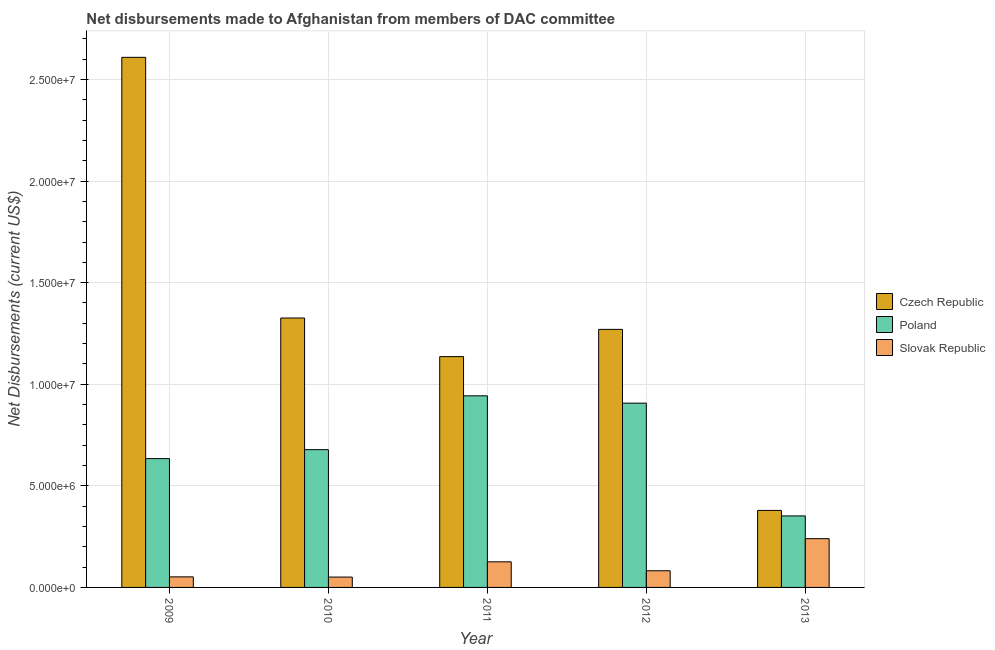How many different coloured bars are there?
Provide a succinct answer. 3. How many groups of bars are there?
Provide a succinct answer. 5. Are the number of bars per tick equal to the number of legend labels?
Keep it short and to the point. Yes. Are the number of bars on each tick of the X-axis equal?
Provide a succinct answer. Yes. How many bars are there on the 2nd tick from the right?
Make the answer very short. 3. What is the label of the 2nd group of bars from the left?
Give a very brief answer. 2010. What is the net disbursements made by czech republic in 2011?
Provide a short and direct response. 1.14e+07. Across all years, what is the maximum net disbursements made by czech republic?
Offer a terse response. 2.61e+07. Across all years, what is the minimum net disbursements made by poland?
Your answer should be compact. 3.52e+06. In which year was the net disbursements made by poland minimum?
Offer a very short reply. 2013. What is the total net disbursements made by poland in the graph?
Keep it short and to the point. 3.51e+07. What is the difference between the net disbursements made by czech republic in 2010 and that in 2011?
Your response must be concise. 1.90e+06. What is the difference between the net disbursements made by poland in 2010 and the net disbursements made by czech republic in 2012?
Offer a terse response. -2.29e+06. What is the average net disbursements made by czech republic per year?
Give a very brief answer. 1.34e+07. In the year 2013, what is the difference between the net disbursements made by czech republic and net disbursements made by poland?
Offer a terse response. 0. What is the ratio of the net disbursements made by poland in 2011 to that in 2012?
Offer a terse response. 1.04. Is the net disbursements made by czech republic in 2009 less than that in 2013?
Your answer should be compact. No. Is the difference between the net disbursements made by slovak republic in 2009 and 2010 greater than the difference between the net disbursements made by czech republic in 2009 and 2010?
Make the answer very short. No. What is the difference between the highest and the second highest net disbursements made by czech republic?
Your answer should be very brief. 1.28e+07. What is the difference between the highest and the lowest net disbursements made by poland?
Offer a very short reply. 5.91e+06. What does the 2nd bar from the left in 2013 represents?
Your answer should be very brief. Poland. What does the 1st bar from the right in 2011 represents?
Provide a succinct answer. Slovak Republic. How many bars are there?
Your response must be concise. 15. Are all the bars in the graph horizontal?
Ensure brevity in your answer.  No. How many years are there in the graph?
Your answer should be compact. 5. How many legend labels are there?
Your response must be concise. 3. How are the legend labels stacked?
Make the answer very short. Vertical. What is the title of the graph?
Keep it short and to the point. Net disbursements made to Afghanistan from members of DAC committee. What is the label or title of the X-axis?
Give a very brief answer. Year. What is the label or title of the Y-axis?
Offer a very short reply. Net Disbursements (current US$). What is the Net Disbursements (current US$) in Czech Republic in 2009?
Keep it short and to the point. 2.61e+07. What is the Net Disbursements (current US$) in Poland in 2009?
Your answer should be very brief. 6.34e+06. What is the Net Disbursements (current US$) in Slovak Republic in 2009?
Offer a terse response. 5.20e+05. What is the Net Disbursements (current US$) of Czech Republic in 2010?
Offer a very short reply. 1.33e+07. What is the Net Disbursements (current US$) in Poland in 2010?
Give a very brief answer. 6.78e+06. What is the Net Disbursements (current US$) in Slovak Republic in 2010?
Ensure brevity in your answer.  5.10e+05. What is the Net Disbursements (current US$) in Czech Republic in 2011?
Ensure brevity in your answer.  1.14e+07. What is the Net Disbursements (current US$) of Poland in 2011?
Keep it short and to the point. 9.43e+06. What is the Net Disbursements (current US$) in Slovak Republic in 2011?
Provide a short and direct response. 1.26e+06. What is the Net Disbursements (current US$) of Czech Republic in 2012?
Ensure brevity in your answer.  1.27e+07. What is the Net Disbursements (current US$) of Poland in 2012?
Offer a terse response. 9.07e+06. What is the Net Disbursements (current US$) of Slovak Republic in 2012?
Offer a terse response. 8.20e+05. What is the Net Disbursements (current US$) in Czech Republic in 2013?
Your response must be concise. 3.79e+06. What is the Net Disbursements (current US$) of Poland in 2013?
Keep it short and to the point. 3.52e+06. What is the Net Disbursements (current US$) of Slovak Republic in 2013?
Offer a very short reply. 2.40e+06. Across all years, what is the maximum Net Disbursements (current US$) of Czech Republic?
Ensure brevity in your answer.  2.61e+07. Across all years, what is the maximum Net Disbursements (current US$) in Poland?
Your answer should be very brief. 9.43e+06. Across all years, what is the maximum Net Disbursements (current US$) of Slovak Republic?
Your response must be concise. 2.40e+06. Across all years, what is the minimum Net Disbursements (current US$) in Czech Republic?
Your response must be concise. 3.79e+06. Across all years, what is the minimum Net Disbursements (current US$) in Poland?
Give a very brief answer. 3.52e+06. Across all years, what is the minimum Net Disbursements (current US$) in Slovak Republic?
Provide a succinct answer. 5.10e+05. What is the total Net Disbursements (current US$) in Czech Republic in the graph?
Provide a short and direct response. 6.72e+07. What is the total Net Disbursements (current US$) in Poland in the graph?
Your response must be concise. 3.51e+07. What is the total Net Disbursements (current US$) in Slovak Republic in the graph?
Offer a terse response. 5.51e+06. What is the difference between the Net Disbursements (current US$) of Czech Republic in 2009 and that in 2010?
Ensure brevity in your answer.  1.28e+07. What is the difference between the Net Disbursements (current US$) of Poland in 2009 and that in 2010?
Make the answer very short. -4.40e+05. What is the difference between the Net Disbursements (current US$) in Slovak Republic in 2009 and that in 2010?
Give a very brief answer. 10000. What is the difference between the Net Disbursements (current US$) in Czech Republic in 2009 and that in 2011?
Give a very brief answer. 1.47e+07. What is the difference between the Net Disbursements (current US$) of Poland in 2009 and that in 2011?
Offer a terse response. -3.09e+06. What is the difference between the Net Disbursements (current US$) in Slovak Republic in 2009 and that in 2011?
Provide a short and direct response. -7.40e+05. What is the difference between the Net Disbursements (current US$) of Czech Republic in 2009 and that in 2012?
Your answer should be compact. 1.34e+07. What is the difference between the Net Disbursements (current US$) of Poland in 2009 and that in 2012?
Your answer should be very brief. -2.73e+06. What is the difference between the Net Disbursements (current US$) in Slovak Republic in 2009 and that in 2012?
Keep it short and to the point. -3.00e+05. What is the difference between the Net Disbursements (current US$) in Czech Republic in 2009 and that in 2013?
Keep it short and to the point. 2.23e+07. What is the difference between the Net Disbursements (current US$) in Poland in 2009 and that in 2013?
Provide a short and direct response. 2.82e+06. What is the difference between the Net Disbursements (current US$) of Slovak Republic in 2009 and that in 2013?
Provide a short and direct response. -1.88e+06. What is the difference between the Net Disbursements (current US$) of Czech Republic in 2010 and that in 2011?
Your answer should be very brief. 1.90e+06. What is the difference between the Net Disbursements (current US$) in Poland in 2010 and that in 2011?
Offer a terse response. -2.65e+06. What is the difference between the Net Disbursements (current US$) in Slovak Republic in 2010 and that in 2011?
Your answer should be compact. -7.50e+05. What is the difference between the Net Disbursements (current US$) in Czech Republic in 2010 and that in 2012?
Offer a terse response. 5.60e+05. What is the difference between the Net Disbursements (current US$) in Poland in 2010 and that in 2012?
Make the answer very short. -2.29e+06. What is the difference between the Net Disbursements (current US$) of Slovak Republic in 2010 and that in 2012?
Provide a short and direct response. -3.10e+05. What is the difference between the Net Disbursements (current US$) in Czech Republic in 2010 and that in 2013?
Your answer should be very brief. 9.47e+06. What is the difference between the Net Disbursements (current US$) of Poland in 2010 and that in 2013?
Offer a very short reply. 3.26e+06. What is the difference between the Net Disbursements (current US$) of Slovak Republic in 2010 and that in 2013?
Make the answer very short. -1.89e+06. What is the difference between the Net Disbursements (current US$) in Czech Republic in 2011 and that in 2012?
Offer a very short reply. -1.34e+06. What is the difference between the Net Disbursements (current US$) of Poland in 2011 and that in 2012?
Keep it short and to the point. 3.60e+05. What is the difference between the Net Disbursements (current US$) in Slovak Republic in 2011 and that in 2012?
Your answer should be very brief. 4.40e+05. What is the difference between the Net Disbursements (current US$) of Czech Republic in 2011 and that in 2013?
Your response must be concise. 7.57e+06. What is the difference between the Net Disbursements (current US$) in Poland in 2011 and that in 2013?
Keep it short and to the point. 5.91e+06. What is the difference between the Net Disbursements (current US$) of Slovak Republic in 2011 and that in 2013?
Your answer should be compact. -1.14e+06. What is the difference between the Net Disbursements (current US$) in Czech Republic in 2012 and that in 2013?
Offer a terse response. 8.91e+06. What is the difference between the Net Disbursements (current US$) in Poland in 2012 and that in 2013?
Offer a terse response. 5.55e+06. What is the difference between the Net Disbursements (current US$) in Slovak Republic in 2012 and that in 2013?
Make the answer very short. -1.58e+06. What is the difference between the Net Disbursements (current US$) of Czech Republic in 2009 and the Net Disbursements (current US$) of Poland in 2010?
Provide a succinct answer. 1.93e+07. What is the difference between the Net Disbursements (current US$) of Czech Republic in 2009 and the Net Disbursements (current US$) of Slovak Republic in 2010?
Ensure brevity in your answer.  2.56e+07. What is the difference between the Net Disbursements (current US$) in Poland in 2009 and the Net Disbursements (current US$) in Slovak Republic in 2010?
Your answer should be compact. 5.83e+06. What is the difference between the Net Disbursements (current US$) in Czech Republic in 2009 and the Net Disbursements (current US$) in Poland in 2011?
Provide a succinct answer. 1.67e+07. What is the difference between the Net Disbursements (current US$) of Czech Republic in 2009 and the Net Disbursements (current US$) of Slovak Republic in 2011?
Keep it short and to the point. 2.48e+07. What is the difference between the Net Disbursements (current US$) of Poland in 2009 and the Net Disbursements (current US$) of Slovak Republic in 2011?
Provide a succinct answer. 5.08e+06. What is the difference between the Net Disbursements (current US$) in Czech Republic in 2009 and the Net Disbursements (current US$) in Poland in 2012?
Offer a very short reply. 1.70e+07. What is the difference between the Net Disbursements (current US$) in Czech Republic in 2009 and the Net Disbursements (current US$) in Slovak Republic in 2012?
Your answer should be very brief. 2.53e+07. What is the difference between the Net Disbursements (current US$) of Poland in 2009 and the Net Disbursements (current US$) of Slovak Republic in 2012?
Offer a very short reply. 5.52e+06. What is the difference between the Net Disbursements (current US$) of Czech Republic in 2009 and the Net Disbursements (current US$) of Poland in 2013?
Your answer should be very brief. 2.26e+07. What is the difference between the Net Disbursements (current US$) of Czech Republic in 2009 and the Net Disbursements (current US$) of Slovak Republic in 2013?
Your response must be concise. 2.37e+07. What is the difference between the Net Disbursements (current US$) in Poland in 2009 and the Net Disbursements (current US$) in Slovak Republic in 2013?
Provide a succinct answer. 3.94e+06. What is the difference between the Net Disbursements (current US$) of Czech Republic in 2010 and the Net Disbursements (current US$) of Poland in 2011?
Give a very brief answer. 3.83e+06. What is the difference between the Net Disbursements (current US$) in Poland in 2010 and the Net Disbursements (current US$) in Slovak Republic in 2011?
Provide a short and direct response. 5.52e+06. What is the difference between the Net Disbursements (current US$) in Czech Republic in 2010 and the Net Disbursements (current US$) in Poland in 2012?
Provide a succinct answer. 4.19e+06. What is the difference between the Net Disbursements (current US$) in Czech Republic in 2010 and the Net Disbursements (current US$) in Slovak Republic in 2012?
Give a very brief answer. 1.24e+07. What is the difference between the Net Disbursements (current US$) of Poland in 2010 and the Net Disbursements (current US$) of Slovak Republic in 2012?
Ensure brevity in your answer.  5.96e+06. What is the difference between the Net Disbursements (current US$) of Czech Republic in 2010 and the Net Disbursements (current US$) of Poland in 2013?
Provide a short and direct response. 9.74e+06. What is the difference between the Net Disbursements (current US$) of Czech Republic in 2010 and the Net Disbursements (current US$) of Slovak Republic in 2013?
Keep it short and to the point. 1.09e+07. What is the difference between the Net Disbursements (current US$) of Poland in 2010 and the Net Disbursements (current US$) of Slovak Republic in 2013?
Ensure brevity in your answer.  4.38e+06. What is the difference between the Net Disbursements (current US$) in Czech Republic in 2011 and the Net Disbursements (current US$) in Poland in 2012?
Your response must be concise. 2.29e+06. What is the difference between the Net Disbursements (current US$) of Czech Republic in 2011 and the Net Disbursements (current US$) of Slovak Republic in 2012?
Make the answer very short. 1.05e+07. What is the difference between the Net Disbursements (current US$) of Poland in 2011 and the Net Disbursements (current US$) of Slovak Republic in 2012?
Ensure brevity in your answer.  8.61e+06. What is the difference between the Net Disbursements (current US$) of Czech Republic in 2011 and the Net Disbursements (current US$) of Poland in 2013?
Make the answer very short. 7.84e+06. What is the difference between the Net Disbursements (current US$) of Czech Republic in 2011 and the Net Disbursements (current US$) of Slovak Republic in 2013?
Provide a short and direct response. 8.96e+06. What is the difference between the Net Disbursements (current US$) of Poland in 2011 and the Net Disbursements (current US$) of Slovak Republic in 2013?
Give a very brief answer. 7.03e+06. What is the difference between the Net Disbursements (current US$) in Czech Republic in 2012 and the Net Disbursements (current US$) in Poland in 2013?
Provide a succinct answer. 9.18e+06. What is the difference between the Net Disbursements (current US$) in Czech Republic in 2012 and the Net Disbursements (current US$) in Slovak Republic in 2013?
Your response must be concise. 1.03e+07. What is the difference between the Net Disbursements (current US$) of Poland in 2012 and the Net Disbursements (current US$) of Slovak Republic in 2013?
Provide a succinct answer. 6.67e+06. What is the average Net Disbursements (current US$) of Czech Republic per year?
Ensure brevity in your answer.  1.34e+07. What is the average Net Disbursements (current US$) of Poland per year?
Your answer should be compact. 7.03e+06. What is the average Net Disbursements (current US$) of Slovak Republic per year?
Give a very brief answer. 1.10e+06. In the year 2009, what is the difference between the Net Disbursements (current US$) in Czech Republic and Net Disbursements (current US$) in Poland?
Make the answer very short. 1.98e+07. In the year 2009, what is the difference between the Net Disbursements (current US$) of Czech Republic and Net Disbursements (current US$) of Slovak Republic?
Ensure brevity in your answer.  2.56e+07. In the year 2009, what is the difference between the Net Disbursements (current US$) in Poland and Net Disbursements (current US$) in Slovak Republic?
Offer a terse response. 5.82e+06. In the year 2010, what is the difference between the Net Disbursements (current US$) in Czech Republic and Net Disbursements (current US$) in Poland?
Offer a very short reply. 6.48e+06. In the year 2010, what is the difference between the Net Disbursements (current US$) in Czech Republic and Net Disbursements (current US$) in Slovak Republic?
Provide a short and direct response. 1.28e+07. In the year 2010, what is the difference between the Net Disbursements (current US$) of Poland and Net Disbursements (current US$) of Slovak Republic?
Offer a very short reply. 6.27e+06. In the year 2011, what is the difference between the Net Disbursements (current US$) in Czech Republic and Net Disbursements (current US$) in Poland?
Ensure brevity in your answer.  1.93e+06. In the year 2011, what is the difference between the Net Disbursements (current US$) in Czech Republic and Net Disbursements (current US$) in Slovak Republic?
Provide a succinct answer. 1.01e+07. In the year 2011, what is the difference between the Net Disbursements (current US$) in Poland and Net Disbursements (current US$) in Slovak Republic?
Offer a terse response. 8.17e+06. In the year 2012, what is the difference between the Net Disbursements (current US$) of Czech Republic and Net Disbursements (current US$) of Poland?
Offer a very short reply. 3.63e+06. In the year 2012, what is the difference between the Net Disbursements (current US$) of Czech Republic and Net Disbursements (current US$) of Slovak Republic?
Give a very brief answer. 1.19e+07. In the year 2012, what is the difference between the Net Disbursements (current US$) in Poland and Net Disbursements (current US$) in Slovak Republic?
Your response must be concise. 8.25e+06. In the year 2013, what is the difference between the Net Disbursements (current US$) of Czech Republic and Net Disbursements (current US$) of Slovak Republic?
Your response must be concise. 1.39e+06. In the year 2013, what is the difference between the Net Disbursements (current US$) in Poland and Net Disbursements (current US$) in Slovak Republic?
Provide a short and direct response. 1.12e+06. What is the ratio of the Net Disbursements (current US$) of Czech Republic in 2009 to that in 2010?
Offer a very short reply. 1.97. What is the ratio of the Net Disbursements (current US$) in Poland in 2009 to that in 2010?
Your answer should be compact. 0.94. What is the ratio of the Net Disbursements (current US$) in Slovak Republic in 2009 to that in 2010?
Your response must be concise. 1.02. What is the ratio of the Net Disbursements (current US$) in Czech Republic in 2009 to that in 2011?
Your answer should be very brief. 2.3. What is the ratio of the Net Disbursements (current US$) of Poland in 2009 to that in 2011?
Offer a very short reply. 0.67. What is the ratio of the Net Disbursements (current US$) of Slovak Republic in 2009 to that in 2011?
Offer a very short reply. 0.41. What is the ratio of the Net Disbursements (current US$) of Czech Republic in 2009 to that in 2012?
Make the answer very short. 2.05. What is the ratio of the Net Disbursements (current US$) in Poland in 2009 to that in 2012?
Offer a terse response. 0.7. What is the ratio of the Net Disbursements (current US$) in Slovak Republic in 2009 to that in 2012?
Your answer should be compact. 0.63. What is the ratio of the Net Disbursements (current US$) of Czech Republic in 2009 to that in 2013?
Keep it short and to the point. 6.88. What is the ratio of the Net Disbursements (current US$) of Poland in 2009 to that in 2013?
Provide a short and direct response. 1.8. What is the ratio of the Net Disbursements (current US$) of Slovak Republic in 2009 to that in 2013?
Your answer should be compact. 0.22. What is the ratio of the Net Disbursements (current US$) in Czech Republic in 2010 to that in 2011?
Your answer should be compact. 1.17. What is the ratio of the Net Disbursements (current US$) in Poland in 2010 to that in 2011?
Provide a succinct answer. 0.72. What is the ratio of the Net Disbursements (current US$) of Slovak Republic in 2010 to that in 2011?
Make the answer very short. 0.4. What is the ratio of the Net Disbursements (current US$) in Czech Republic in 2010 to that in 2012?
Ensure brevity in your answer.  1.04. What is the ratio of the Net Disbursements (current US$) of Poland in 2010 to that in 2012?
Offer a very short reply. 0.75. What is the ratio of the Net Disbursements (current US$) in Slovak Republic in 2010 to that in 2012?
Your answer should be very brief. 0.62. What is the ratio of the Net Disbursements (current US$) of Czech Republic in 2010 to that in 2013?
Make the answer very short. 3.5. What is the ratio of the Net Disbursements (current US$) of Poland in 2010 to that in 2013?
Provide a short and direct response. 1.93. What is the ratio of the Net Disbursements (current US$) in Slovak Republic in 2010 to that in 2013?
Ensure brevity in your answer.  0.21. What is the ratio of the Net Disbursements (current US$) of Czech Republic in 2011 to that in 2012?
Offer a terse response. 0.89. What is the ratio of the Net Disbursements (current US$) of Poland in 2011 to that in 2012?
Provide a succinct answer. 1.04. What is the ratio of the Net Disbursements (current US$) of Slovak Republic in 2011 to that in 2012?
Give a very brief answer. 1.54. What is the ratio of the Net Disbursements (current US$) in Czech Republic in 2011 to that in 2013?
Provide a succinct answer. 3. What is the ratio of the Net Disbursements (current US$) in Poland in 2011 to that in 2013?
Your answer should be very brief. 2.68. What is the ratio of the Net Disbursements (current US$) of Slovak Republic in 2011 to that in 2013?
Provide a succinct answer. 0.53. What is the ratio of the Net Disbursements (current US$) in Czech Republic in 2012 to that in 2013?
Your answer should be very brief. 3.35. What is the ratio of the Net Disbursements (current US$) of Poland in 2012 to that in 2013?
Ensure brevity in your answer.  2.58. What is the ratio of the Net Disbursements (current US$) in Slovak Republic in 2012 to that in 2013?
Your answer should be very brief. 0.34. What is the difference between the highest and the second highest Net Disbursements (current US$) in Czech Republic?
Ensure brevity in your answer.  1.28e+07. What is the difference between the highest and the second highest Net Disbursements (current US$) of Poland?
Offer a terse response. 3.60e+05. What is the difference between the highest and the second highest Net Disbursements (current US$) in Slovak Republic?
Offer a terse response. 1.14e+06. What is the difference between the highest and the lowest Net Disbursements (current US$) in Czech Republic?
Offer a terse response. 2.23e+07. What is the difference between the highest and the lowest Net Disbursements (current US$) of Poland?
Make the answer very short. 5.91e+06. What is the difference between the highest and the lowest Net Disbursements (current US$) of Slovak Republic?
Keep it short and to the point. 1.89e+06. 